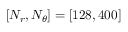Convert formula to latex. <formula><loc_0><loc_0><loc_500><loc_500>\left [ N _ { r } , N _ { \theta } \right ] = \left [ 1 2 8 , 4 0 0 \right ]</formula> 